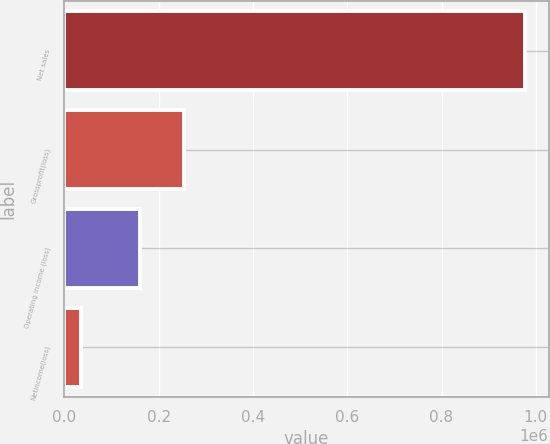Convert chart. <chart><loc_0><loc_0><loc_500><loc_500><bar_chart><fcel>Net sales<fcel>Grossprofit(loss)<fcel>Operating income (loss)<fcel>Netincome(loss)<nl><fcel>978059<fcel>254612<fcel>160298<fcel>34924<nl></chart> 